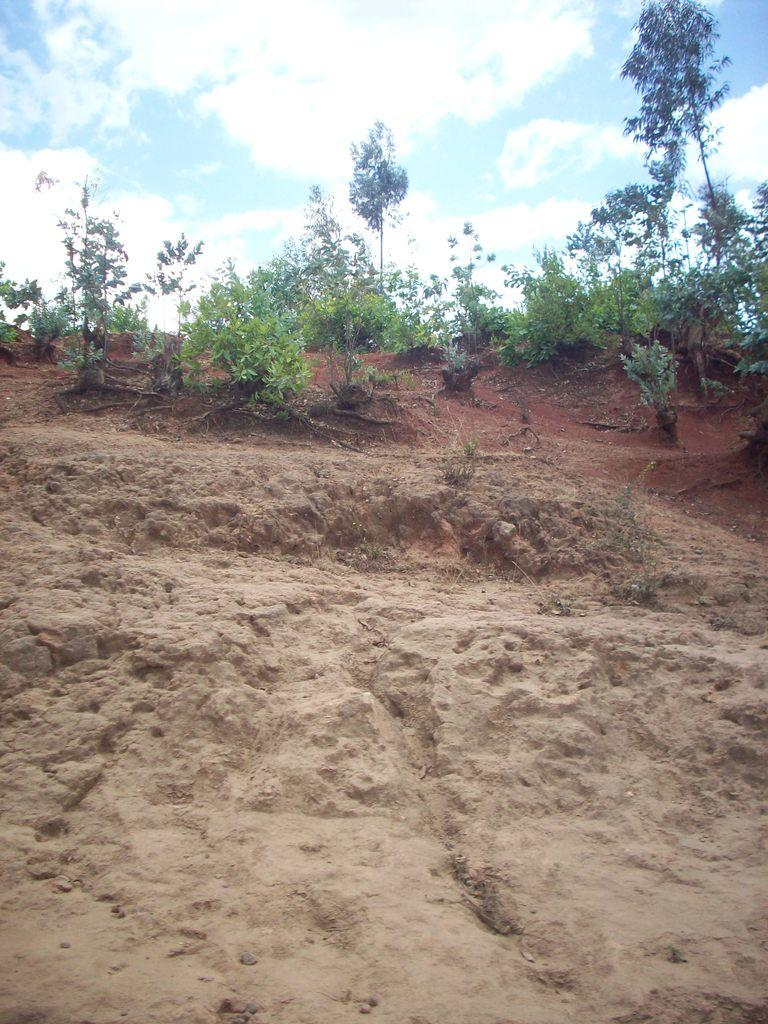What is in the foreground of the image? There is sand in the foreground of the image. What can be seen in the background of the image? There are plants and the sky visible in the background of the image. Where is the drawer located in the image? There is no drawer present in the image. What type of science experiment can be seen in the image? There is no science experiment present in the image. 